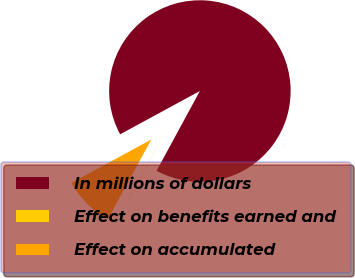Convert chart. <chart><loc_0><loc_0><loc_500><loc_500><pie_chart><fcel>In millions of dollars<fcel>Effect on benefits earned and<fcel>Effect on accumulated<nl><fcel>90.83%<fcel>0.05%<fcel>9.12%<nl></chart> 